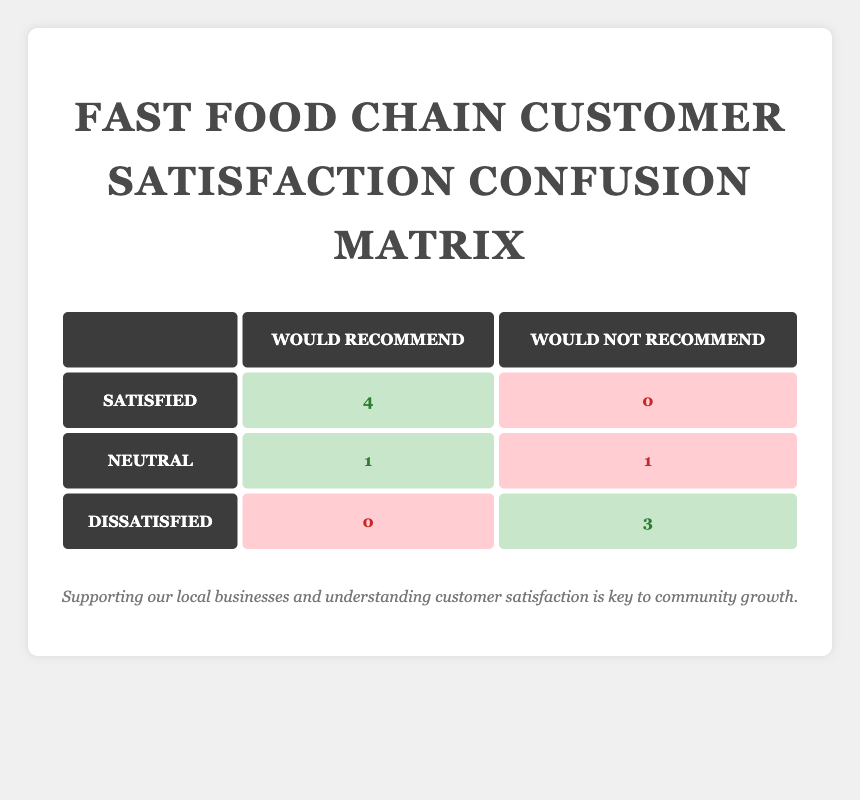What is the total number of satisfied customers who would recommend the fast food chain? From the table, we see that there are 4 satisfied customers who would recommend the fast food chain (shown in the first row under “Satisfied”).
Answer: 4 How many customers are neutral and would not recommend the fast food chain? The table indicates that there is 1 neutral customer who would not recommend (seen in the second row under “Neutral” in the “Would Not Recommend” column).
Answer: 1 Is it true that no dissatisfied customers would recommend the fast food chain? In the table, the “Dissatisfied” row shows 0 customers in the “Would Recommend” column, confirming that no dissatisfied customers would recommend the chain.
Answer: Yes What is the ratio of satisfied customers to dissatisfied customers? The table indicates there are 4 satisfied customers and 3 dissatisfied customers. The ratio is calculated as 4/3.
Answer: 4:3 How many total customers were surveyed? By summing up all the customers listed, there are 10 customer entries total across all responses, which indicates the total surveyed.
Answer: 10 What is the total number of customers who would recommend the fast food chain? Adding the satisfied customers (4) who would recommend and the neutral customer (1) who would recommend together gives a total of 5 customers who would recommend the fast food chain.
Answer: 5 How many customers did not recommend the fast food chain? From the table, there are 3 dissatisfied customers (shown in the last row) and 1 neutral customer who did not recommend, totaling 4 customers who did not recommend the fast food chain.
Answer: 4 What percentage of satisfied customers would recommend the fast food chain? Out of 4 satisfied customers, all 4 (100%) would recommend the fast food chain, as shown in the “Satisfied” row under “Would Recommend”.
Answer: 100% What is the total number of customers who frequented the fast food chain occasionally? From the data, we have 3 customers with "Occasional" visit frequency (customer IDs 2, 5, and 9).
Answer: 3 